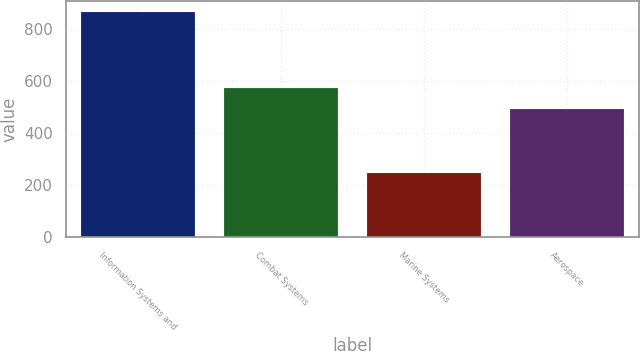<chart> <loc_0><loc_0><loc_500><loc_500><bar_chart><fcel>Information Systems and<fcel>Combat Systems<fcel>Marine Systems<fcel>Aerospace<nl><fcel>865<fcel>576<fcel>249<fcel>495<nl></chart> 